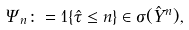Convert formula to latex. <formula><loc_0><loc_0><loc_500><loc_500>\Psi _ { n } \colon = 1 \{ \hat { \tau } \leq n \} \in \sigma ( \hat { Y } ^ { n } ) ,</formula> 